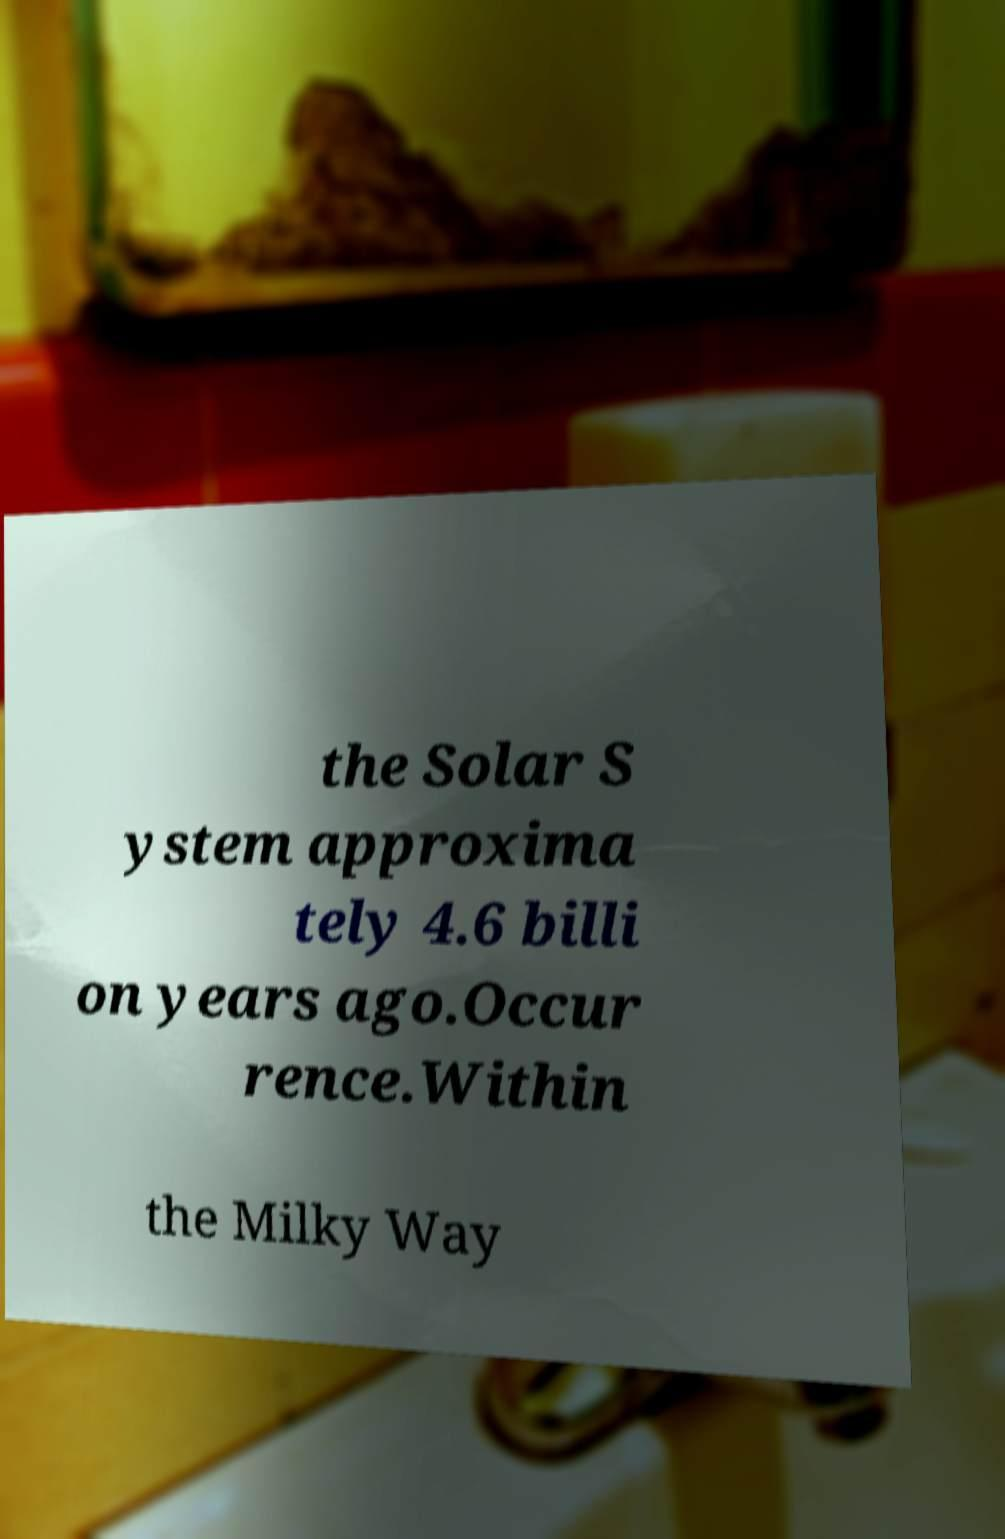Can you accurately transcribe the text from the provided image for me? the Solar S ystem approxima tely 4.6 billi on years ago.Occur rence.Within the Milky Way 